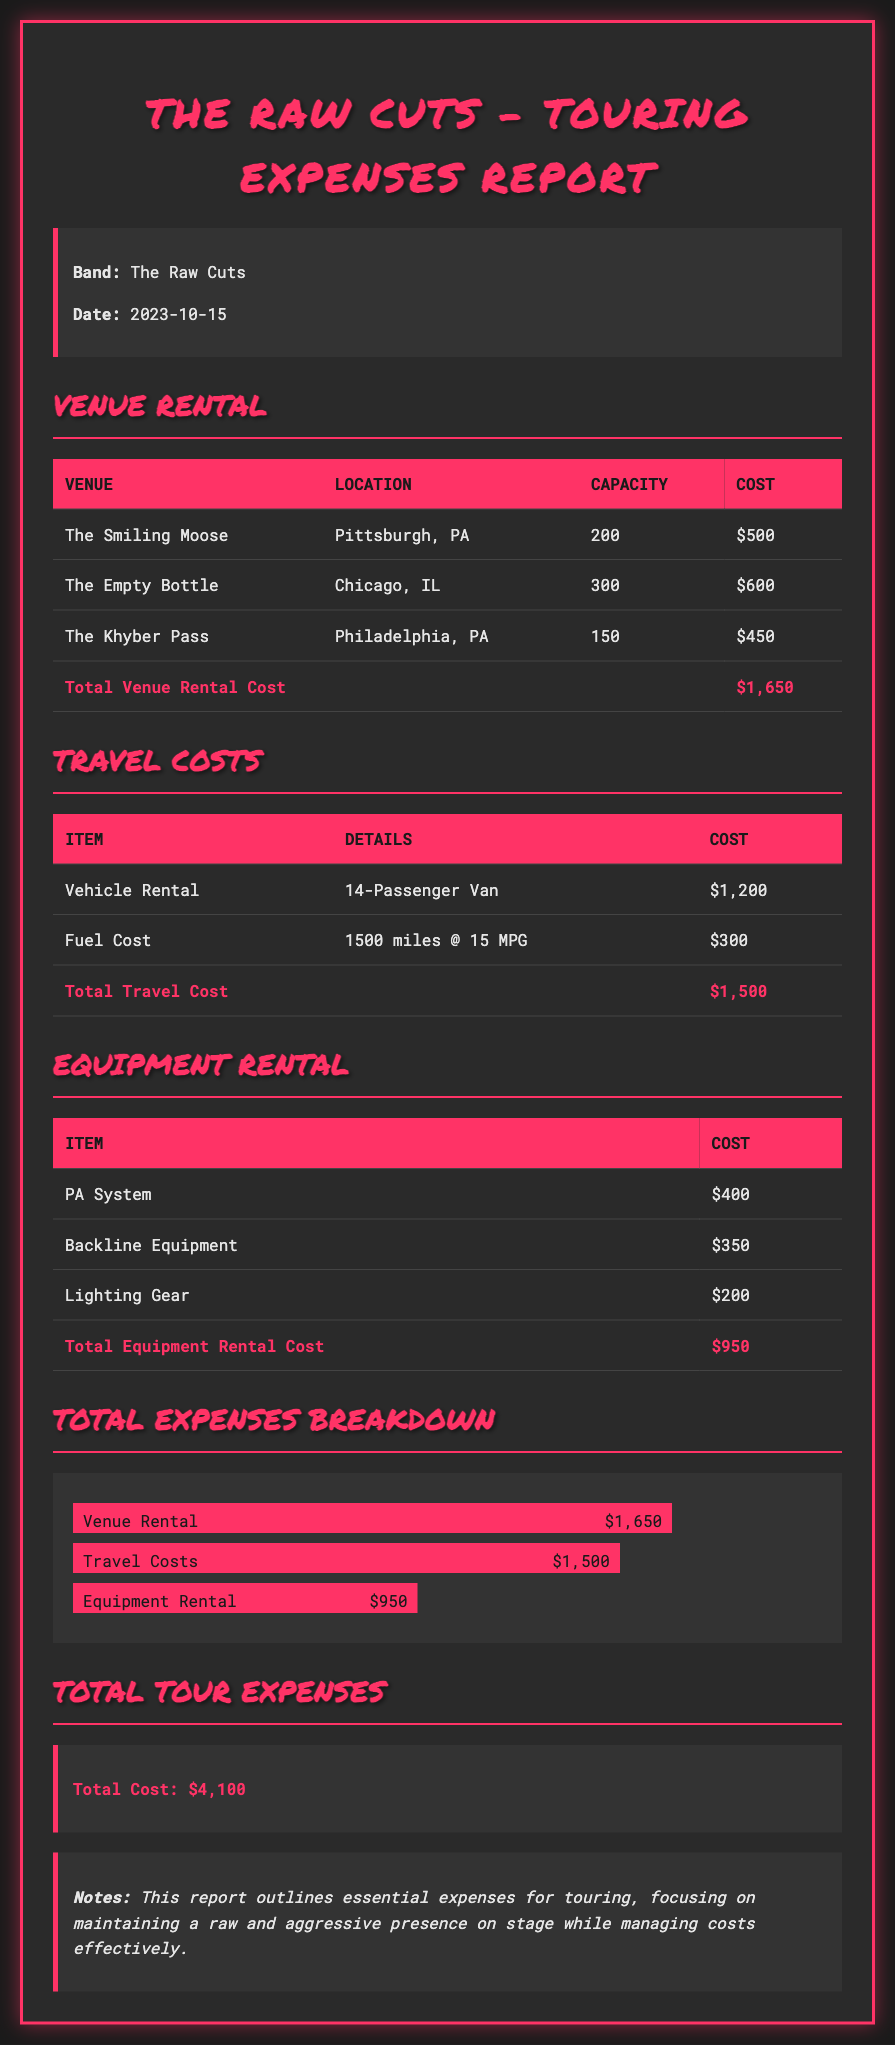what is the total venue rental cost? The total venue rental cost is listed at the bottom of the venue rental section, summing up the individual venue costs.
Answer: $1,650 what is the capacity of The Empty Bottle? The capacity of The Empty Bottle is provided in the venue rental table.
Answer: 300 how much was spent on travel costs? The total travel cost is detailed at the end of the travel costs section.
Answer: $1,500 what type of vehicle was rented? The details of the vehicle rented are specified in the travel costs table.
Answer: 14-Passenger Van what was the cost of the PA System? The cost for the PA System is listed in the equipment rental section.
Answer: $400 what is the total cost of equipment rental? The total equipment rental cost is stated at the bottom of the equipment rental table.
Answer: $950 what is the overall total tour expense? The overall total tour expense is mentioned in the total tour expenses section.
Answer: $4,100 which venue had the highest rental cost? The highest rental cost can be determined by comparing the costs listed for each venue.
Answer: The Empty Bottle what percentage of the total expenses is attributed to venue rental? This requires calculating the portion of venue rental costs compared to the total expenses.
Answer: 40% 